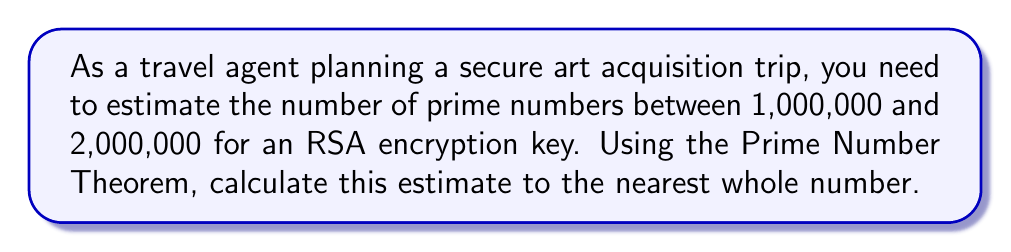Provide a solution to this math problem. To estimate the number of primes within a given range using the Prime Number Theorem, we follow these steps:

1. The Prime Number Theorem states that the number of primes less than or equal to x is approximately:

   $$\pi(x) \approx \frac{x}{\ln(x)}$$

2. We need to find the difference between the number of primes up to 2,000,000 and up to 1,000,000:

   $$\text{Estimate} = \pi(2,000,000) - \pi(1,000,000)$$

3. Calculate $\pi(2,000,000)$:
   $$\pi(2,000,000) \approx \frac{2,000,000}{\ln(2,000,000)} \approx 148,933.1$$

4. Calculate $\pi(1,000,000)$:
   $$\pi(1,000,000) \approx \frac{1,000,000}{\ln(1,000,000)} \approx 72,382.4$$

5. Subtract to get the estimate:
   $$\text{Estimate} \approx 148,933.1 - 72,382.4 \approx 76,550.7$$

6. Round to the nearest whole number:
   $$\text{Estimate} \approx 76,551$$
Answer: 76,551 